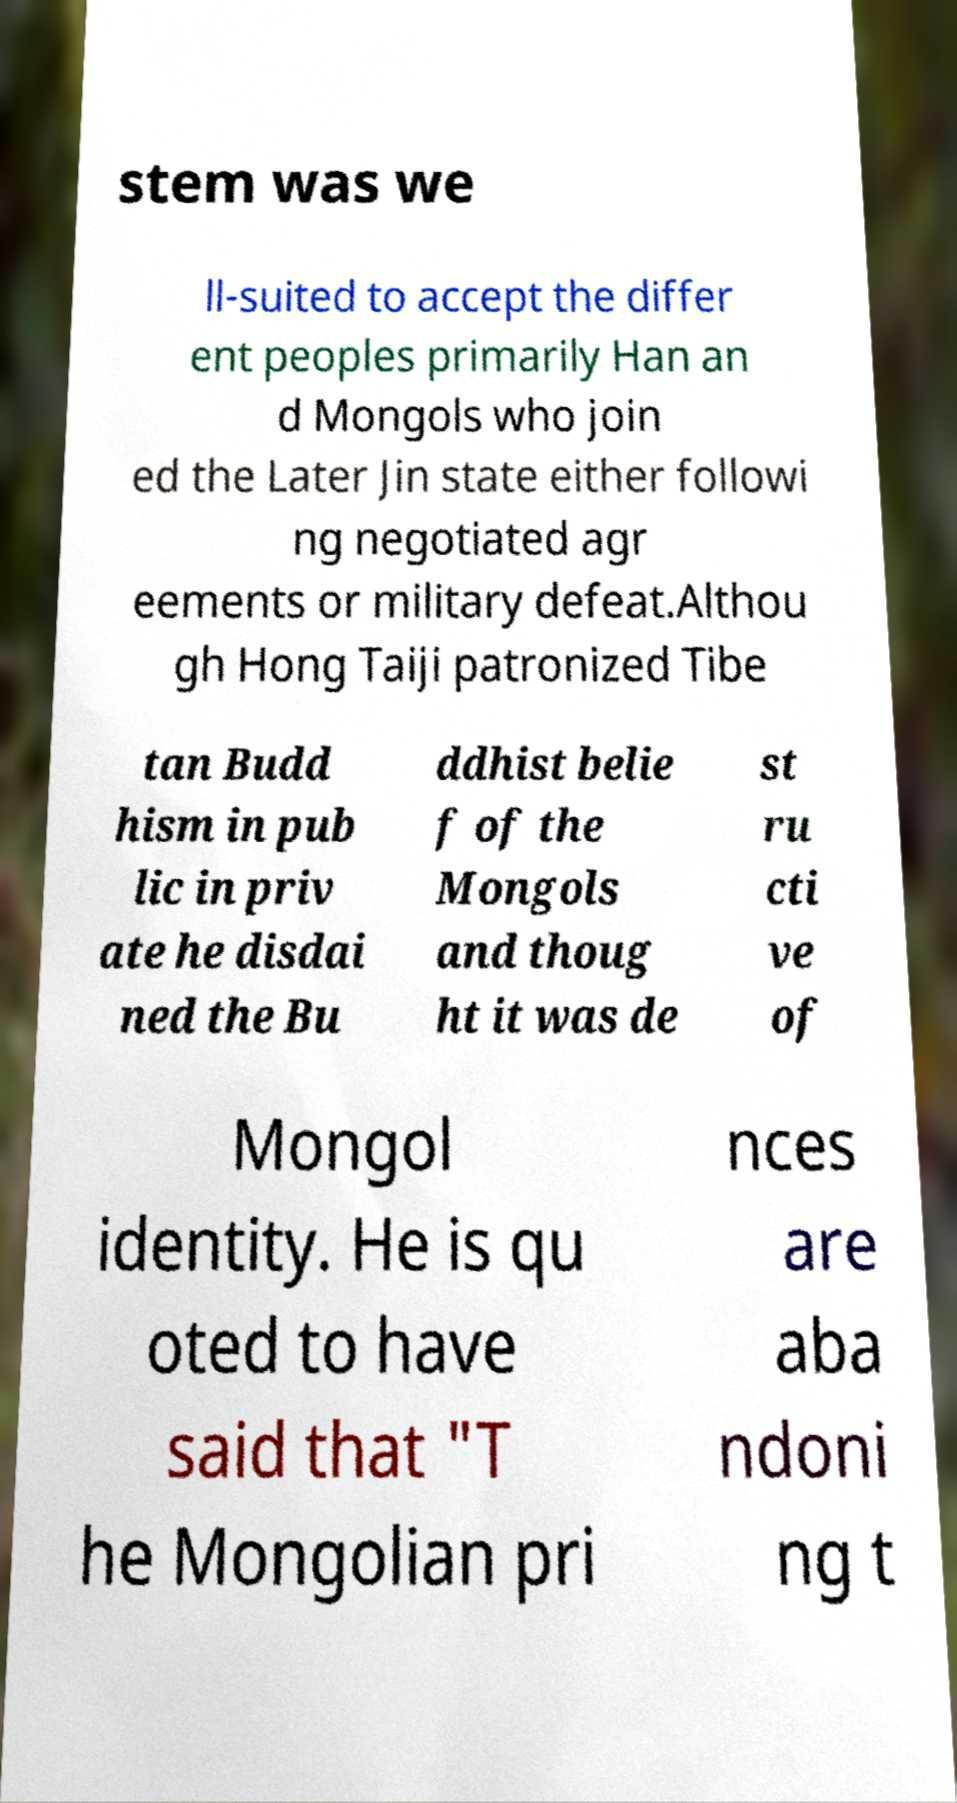Please identify and transcribe the text found in this image. stem was we ll-suited to accept the differ ent peoples primarily Han an d Mongols who join ed the Later Jin state either followi ng negotiated agr eements or military defeat.Althou gh Hong Taiji patronized Tibe tan Budd hism in pub lic in priv ate he disdai ned the Bu ddhist belie f of the Mongols and thoug ht it was de st ru cti ve of Mongol identity. He is qu oted to have said that "T he Mongolian pri nces are aba ndoni ng t 